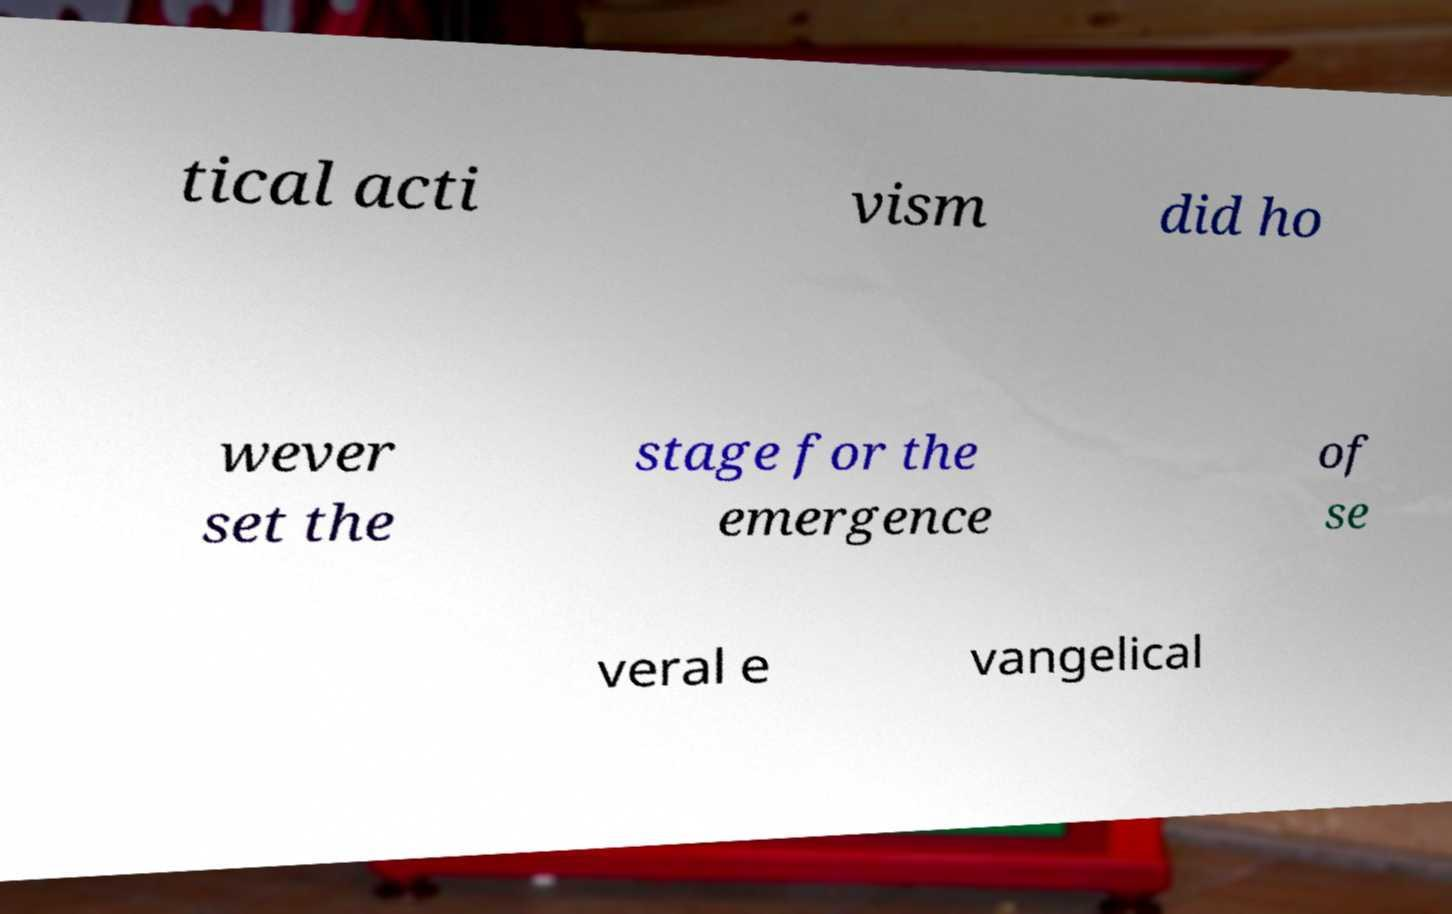Could you assist in decoding the text presented in this image and type it out clearly? tical acti vism did ho wever set the stage for the emergence of se veral e vangelical 